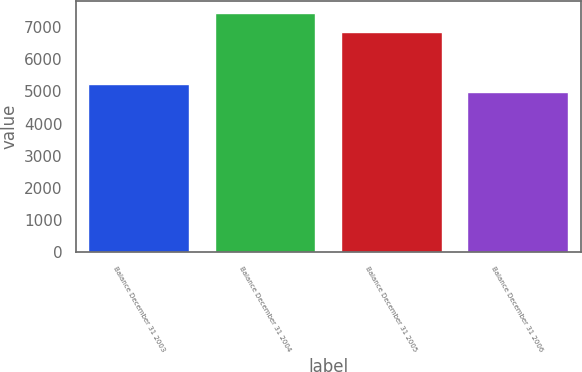<chart> <loc_0><loc_0><loc_500><loc_500><bar_chart><fcel>Balance December 31 2003<fcel>Balance December 31 2004<fcel>Balance December 31 2005<fcel>Balance December 31 2006<nl><fcel>5236<fcel>7432<fcel>6847<fcel>4992<nl></chart> 